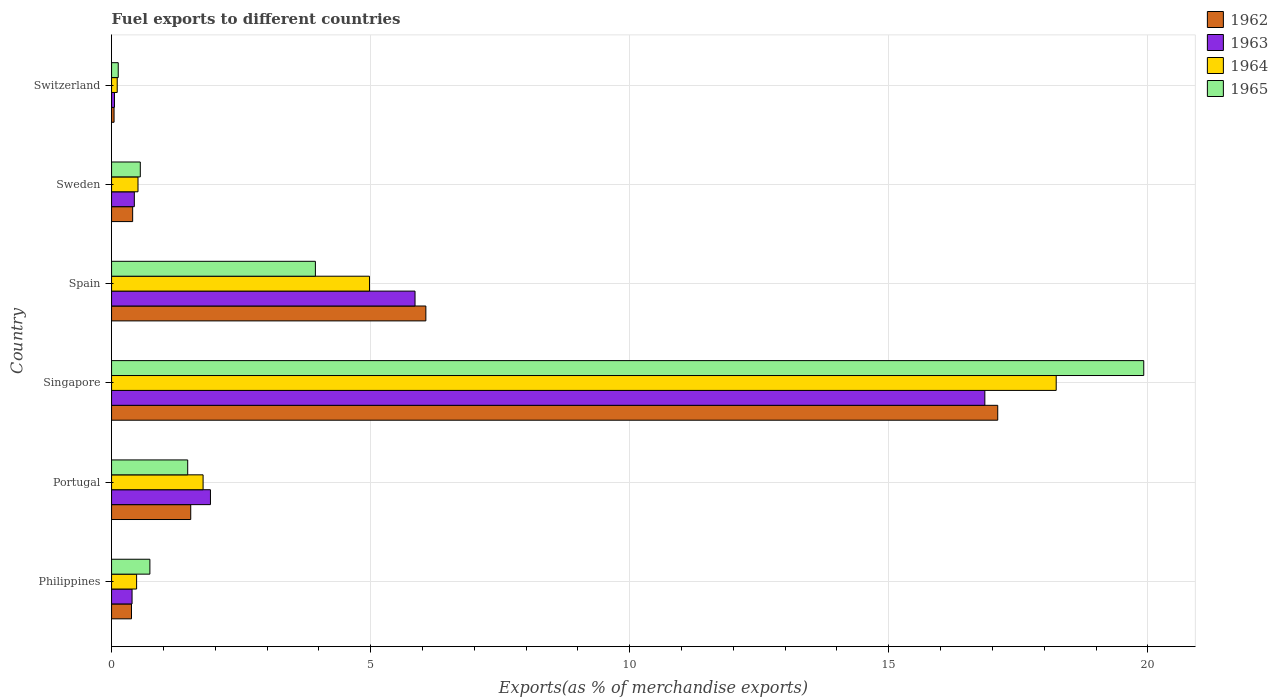Are the number of bars per tick equal to the number of legend labels?
Your answer should be very brief. Yes. Are the number of bars on each tick of the Y-axis equal?
Your answer should be compact. Yes. How many bars are there on the 4th tick from the top?
Your answer should be compact. 4. What is the label of the 2nd group of bars from the top?
Your response must be concise. Sweden. In how many cases, is the number of bars for a given country not equal to the number of legend labels?
Your response must be concise. 0. What is the percentage of exports to different countries in 1962 in Spain?
Give a very brief answer. 6.07. Across all countries, what is the maximum percentage of exports to different countries in 1963?
Your answer should be compact. 16.85. Across all countries, what is the minimum percentage of exports to different countries in 1962?
Provide a short and direct response. 0.05. In which country was the percentage of exports to different countries in 1965 maximum?
Your response must be concise. Singapore. In which country was the percentage of exports to different countries in 1962 minimum?
Give a very brief answer. Switzerland. What is the total percentage of exports to different countries in 1965 in the graph?
Offer a very short reply. 26.75. What is the difference between the percentage of exports to different countries in 1965 in Spain and that in Switzerland?
Make the answer very short. 3.81. What is the difference between the percentage of exports to different countries in 1965 in Switzerland and the percentage of exports to different countries in 1963 in Singapore?
Keep it short and to the point. -16.73. What is the average percentage of exports to different countries in 1963 per country?
Offer a terse response. 4.25. What is the difference between the percentage of exports to different countries in 1964 and percentage of exports to different countries in 1962 in Philippines?
Your answer should be very brief. 0.1. What is the ratio of the percentage of exports to different countries in 1962 in Philippines to that in Spain?
Keep it short and to the point. 0.06. What is the difference between the highest and the second highest percentage of exports to different countries in 1963?
Your answer should be very brief. 11. What is the difference between the highest and the lowest percentage of exports to different countries in 1963?
Offer a terse response. 16.8. What does the 2nd bar from the bottom in Portugal represents?
Give a very brief answer. 1963. Is it the case that in every country, the sum of the percentage of exports to different countries in 1963 and percentage of exports to different countries in 1965 is greater than the percentage of exports to different countries in 1964?
Offer a terse response. Yes. How many bars are there?
Ensure brevity in your answer.  24. Are all the bars in the graph horizontal?
Your response must be concise. Yes. Are the values on the major ticks of X-axis written in scientific E-notation?
Your response must be concise. No. Does the graph contain grids?
Your response must be concise. Yes. Where does the legend appear in the graph?
Offer a very short reply. Top right. How many legend labels are there?
Ensure brevity in your answer.  4. What is the title of the graph?
Your answer should be very brief. Fuel exports to different countries. Does "2002" appear as one of the legend labels in the graph?
Keep it short and to the point. No. What is the label or title of the X-axis?
Your answer should be very brief. Exports(as % of merchandise exports). What is the Exports(as % of merchandise exports) in 1962 in Philippines?
Your answer should be very brief. 0.38. What is the Exports(as % of merchandise exports) of 1963 in Philippines?
Keep it short and to the point. 0.4. What is the Exports(as % of merchandise exports) in 1964 in Philippines?
Provide a short and direct response. 0.48. What is the Exports(as % of merchandise exports) in 1965 in Philippines?
Offer a terse response. 0.74. What is the Exports(as % of merchandise exports) in 1962 in Portugal?
Offer a terse response. 1.53. What is the Exports(as % of merchandise exports) of 1963 in Portugal?
Provide a succinct answer. 1.91. What is the Exports(as % of merchandise exports) in 1964 in Portugal?
Your response must be concise. 1.77. What is the Exports(as % of merchandise exports) of 1965 in Portugal?
Provide a succinct answer. 1.47. What is the Exports(as % of merchandise exports) in 1962 in Singapore?
Offer a very short reply. 17.1. What is the Exports(as % of merchandise exports) of 1963 in Singapore?
Provide a succinct answer. 16.85. What is the Exports(as % of merchandise exports) in 1964 in Singapore?
Your answer should be compact. 18.23. What is the Exports(as % of merchandise exports) of 1965 in Singapore?
Offer a very short reply. 19.92. What is the Exports(as % of merchandise exports) of 1962 in Spain?
Make the answer very short. 6.07. What is the Exports(as % of merchandise exports) in 1963 in Spain?
Keep it short and to the point. 5.86. What is the Exports(as % of merchandise exports) in 1964 in Spain?
Give a very brief answer. 4.98. What is the Exports(as % of merchandise exports) of 1965 in Spain?
Offer a very short reply. 3.93. What is the Exports(as % of merchandise exports) in 1962 in Sweden?
Your answer should be very brief. 0.41. What is the Exports(as % of merchandise exports) in 1963 in Sweden?
Offer a very short reply. 0.44. What is the Exports(as % of merchandise exports) of 1964 in Sweden?
Offer a very short reply. 0.51. What is the Exports(as % of merchandise exports) in 1965 in Sweden?
Offer a terse response. 0.55. What is the Exports(as % of merchandise exports) in 1962 in Switzerland?
Keep it short and to the point. 0.05. What is the Exports(as % of merchandise exports) of 1963 in Switzerland?
Offer a terse response. 0.06. What is the Exports(as % of merchandise exports) in 1964 in Switzerland?
Keep it short and to the point. 0.11. What is the Exports(as % of merchandise exports) of 1965 in Switzerland?
Offer a terse response. 0.13. Across all countries, what is the maximum Exports(as % of merchandise exports) of 1962?
Offer a very short reply. 17.1. Across all countries, what is the maximum Exports(as % of merchandise exports) in 1963?
Give a very brief answer. 16.85. Across all countries, what is the maximum Exports(as % of merchandise exports) in 1964?
Provide a short and direct response. 18.23. Across all countries, what is the maximum Exports(as % of merchandise exports) of 1965?
Provide a succinct answer. 19.92. Across all countries, what is the minimum Exports(as % of merchandise exports) in 1962?
Keep it short and to the point. 0.05. Across all countries, what is the minimum Exports(as % of merchandise exports) in 1963?
Provide a short and direct response. 0.06. Across all countries, what is the minimum Exports(as % of merchandise exports) of 1964?
Offer a very short reply. 0.11. Across all countries, what is the minimum Exports(as % of merchandise exports) of 1965?
Offer a terse response. 0.13. What is the total Exports(as % of merchandise exports) of 1962 in the graph?
Your answer should be very brief. 25.54. What is the total Exports(as % of merchandise exports) of 1963 in the graph?
Provide a succinct answer. 25.51. What is the total Exports(as % of merchandise exports) of 1964 in the graph?
Give a very brief answer. 26.08. What is the total Exports(as % of merchandise exports) in 1965 in the graph?
Provide a succinct answer. 26.75. What is the difference between the Exports(as % of merchandise exports) of 1962 in Philippines and that in Portugal?
Give a very brief answer. -1.14. What is the difference between the Exports(as % of merchandise exports) in 1963 in Philippines and that in Portugal?
Offer a very short reply. -1.51. What is the difference between the Exports(as % of merchandise exports) in 1964 in Philippines and that in Portugal?
Offer a very short reply. -1.28. What is the difference between the Exports(as % of merchandise exports) in 1965 in Philippines and that in Portugal?
Your answer should be compact. -0.73. What is the difference between the Exports(as % of merchandise exports) of 1962 in Philippines and that in Singapore?
Provide a succinct answer. -16.72. What is the difference between the Exports(as % of merchandise exports) of 1963 in Philippines and that in Singapore?
Your response must be concise. -16.46. What is the difference between the Exports(as % of merchandise exports) in 1964 in Philippines and that in Singapore?
Offer a terse response. -17.75. What is the difference between the Exports(as % of merchandise exports) of 1965 in Philippines and that in Singapore?
Your answer should be compact. -19.18. What is the difference between the Exports(as % of merchandise exports) in 1962 in Philippines and that in Spain?
Provide a short and direct response. -5.68. What is the difference between the Exports(as % of merchandise exports) in 1963 in Philippines and that in Spain?
Offer a very short reply. -5.46. What is the difference between the Exports(as % of merchandise exports) of 1964 in Philippines and that in Spain?
Provide a succinct answer. -4.49. What is the difference between the Exports(as % of merchandise exports) of 1965 in Philippines and that in Spain?
Your answer should be compact. -3.19. What is the difference between the Exports(as % of merchandise exports) of 1962 in Philippines and that in Sweden?
Make the answer very short. -0.02. What is the difference between the Exports(as % of merchandise exports) of 1963 in Philippines and that in Sweden?
Ensure brevity in your answer.  -0.04. What is the difference between the Exports(as % of merchandise exports) of 1964 in Philippines and that in Sweden?
Provide a succinct answer. -0.03. What is the difference between the Exports(as % of merchandise exports) in 1965 in Philippines and that in Sweden?
Offer a terse response. 0.19. What is the difference between the Exports(as % of merchandise exports) in 1962 in Philippines and that in Switzerland?
Provide a short and direct response. 0.34. What is the difference between the Exports(as % of merchandise exports) of 1963 in Philippines and that in Switzerland?
Your answer should be very brief. 0.34. What is the difference between the Exports(as % of merchandise exports) of 1964 in Philippines and that in Switzerland?
Your answer should be compact. 0.37. What is the difference between the Exports(as % of merchandise exports) of 1965 in Philippines and that in Switzerland?
Give a very brief answer. 0.61. What is the difference between the Exports(as % of merchandise exports) in 1962 in Portugal and that in Singapore?
Offer a terse response. -15.58. What is the difference between the Exports(as % of merchandise exports) in 1963 in Portugal and that in Singapore?
Your answer should be very brief. -14.95. What is the difference between the Exports(as % of merchandise exports) in 1964 in Portugal and that in Singapore?
Give a very brief answer. -16.47. What is the difference between the Exports(as % of merchandise exports) of 1965 in Portugal and that in Singapore?
Offer a very short reply. -18.45. What is the difference between the Exports(as % of merchandise exports) of 1962 in Portugal and that in Spain?
Keep it short and to the point. -4.54. What is the difference between the Exports(as % of merchandise exports) of 1963 in Portugal and that in Spain?
Your answer should be very brief. -3.95. What is the difference between the Exports(as % of merchandise exports) of 1964 in Portugal and that in Spain?
Your answer should be compact. -3.21. What is the difference between the Exports(as % of merchandise exports) in 1965 in Portugal and that in Spain?
Offer a terse response. -2.46. What is the difference between the Exports(as % of merchandise exports) in 1962 in Portugal and that in Sweden?
Offer a terse response. 1.12. What is the difference between the Exports(as % of merchandise exports) in 1963 in Portugal and that in Sweden?
Give a very brief answer. 1.47. What is the difference between the Exports(as % of merchandise exports) in 1964 in Portugal and that in Sweden?
Make the answer very short. 1.26. What is the difference between the Exports(as % of merchandise exports) of 1965 in Portugal and that in Sweden?
Your answer should be very brief. 0.91. What is the difference between the Exports(as % of merchandise exports) of 1962 in Portugal and that in Switzerland?
Ensure brevity in your answer.  1.48. What is the difference between the Exports(as % of merchandise exports) of 1963 in Portugal and that in Switzerland?
Provide a succinct answer. 1.85. What is the difference between the Exports(as % of merchandise exports) of 1964 in Portugal and that in Switzerland?
Provide a succinct answer. 1.66. What is the difference between the Exports(as % of merchandise exports) of 1965 in Portugal and that in Switzerland?
Ensure brevity in your answer.  1.34. What is the difference between the Exports(as % of merchandise exports) in 1962 in Singapore and that in Spain?
Offer a very short reply. 11.04. What is the difference between the Exports(as % of merchandise exports) in 1963 in Singapore and that in Spain?
Offer a very short reply. 11. What is the difference between the Exports(as % of merchandise exports) in 1964 in Singapore and that in Spain?
Provide a succinct answer. 13.25. What is the difference between the Exports(as % of merchandise exports) of 1965 in Singapore and that in Spain?
Make the answer very short. 15.99. What is the difference between the Exports(as % of merchandise exports) in 1962 in Singapore and that in Sweden?
Your answer should be compact. 16.7. What is the difference between the Exports(as % of merchandise exports) in 1963 in Singapore and that in Sweden?
Ensure brevity in your answer.  16.42. What is the difference between the Exports(as % of merchandise exports) of 1964 in Singapore and that in Sweden?
Provide a short and direct response. 17.72. What is the difference between the Exports(as % of merchandise exports) of 1965 in Singapore and that in Sweden?
Make the answer very short. 19.37. What is the difference between the Exports(as % of merchandise exports) of 1962 in Singapore and that in Switzerland?
Your answer should be very brief. 17.06. What is the difference between the Exports(as % of merchandise exports) of 1963 in Singapore and that in Switzerland?
Offer a terse response. 16.8. What is the difference between the Exports(as % of merchandise exports) of 1964 in Singapore and that in Switzerland?
Offer a terse response. 18.12. What is the difference between the Exports(as % of merchandise exports) in 1965 in Singapore and that in Switzerland?
Your answer should be very brief. 19.79. What is the difference between the Exports(as % of merchandise exports) of 1962 in Spain and that in Sweden?
Offer a terse response. 5.66. What is the difference between the Exports(as % of merchandise exports) of 1963 in Spain and that in Sweden?
Keep it short and to the point. 5.42. What is the difference between the Exports(as % of merchandise exports) of 1964 in Spain and that in Sweden?
Give a very brief answer. 4.47. What is the difference between the Exports(as % of merchandise exports) of 1965 in Spain and that in Sweden?
Your answer should be very brief. 3.38. What is the difference between the Exports(as % of merchandise exports) of 1962 in Spain and that in Switzerland?
Provide a succinct answer. 6.02. What is the difference between the Exports(as % of merchandise exports) of 1963 in Spain and that in Switzerland?
Give a very brief answer. 5.8. What is the difference between the Exports(as % of merchandise exports) of 1964 in Spain and that in Switzerland?
Provide a succinct answer. 4.87. What is the difference between the Exports(as % of merchandise exports) of 1965 in Spain and that in Switzerland?
Your answer should be very brief. 3.81. What is the difference between the Exports(as % of merchandise exports) of 1962 in Sweden and that in Switzerland?
Your answer should be compact. 0.36. What is the difference between the Exports(as % of merchandise exports) of 1963 in Sweden and that in Switzerland?
Provide a succinct answer. 0.38. What is the difference between the Exports(as % of merchandise exports) of 1964 in Sweden and that in Switzerland?
Make the answer very short. 0.4. What is the difference between the Exports(as % of merchandise exports) of 1965 in Sweden and that in Switzerland?
Offer a very short reply. 0.43. What is the difference between the Exports(as % of merchandise exports) in 1962 in Philippines and the Exports(as % of merchandise exports) in 1963 in Portugal?
Provide a short and direct response. -1.52. What is the difference between the Exports(as % of merchandise exports) of 1962 in Philippines and the Exports(as % of merchandise exports) of 1964 in Portugal?
Make the answer very short. -1.38. What is the difference between the Exports(as % of merchandise exports) in 1962 in Philippines and the Exports(as % of merchandise exports) in 1965 in Portugal?
Ensure brevity in your answer.  -1.08. What is the difference between the Exports(as % of merchandise exports) of 1963 in Philippines and the Exports(as % of merchandise exports) of 1964 in Portugal?
Offer a terse response. -1.37. What is the difference between the Exports(as % of merchandise exports) of 1963 in Philippines and the Exports(as % of merchandise exports) of 1965 in Portugal?
Provide a short and direct response. -1.07. What is the difference between the Exports(as % of merchandise exports) of 1964 in Philippines and the Exports(as % of merchandise exports) of 1965 in Portugal?
Keep it short and to the point. -0.99. What is the difference between the Exports(as % of merchandise exports) in 1962 in Philippines and the Exports(as % of merchandise exports) in 1963 in Singapore?
Provide a succinct answer. -16.47. What is the difference between the Exports(as % of merchandise exports) in 1962 in Philippines and the Exports(as % of merchandise exports) in 1964 in Singapore?
Provide a succinct answer. -17.85. What is the difference between the Exports(as % of merchandise exports) in 1962 in Philippines and the Exports(as % of merchandise exports) in 1965 in Singapore?
Give a very brief answer. -19.54. What is the difference between the Exports(as % of merchandise exports) of 1963 in Philippines and the Exports(as % of merchandise exports) of 1964 in Singapore?
Ensure brevity in your answer.  -17.84. What is the difference between the Exports(as % of merchandise exports) of 1963 in Philippines and the Exports(as % of merchandise exports) of 1965 in Singapore?
Offer a terse response. -19.53. What is the difference between the Exports(as % of merchandise exports) of 1964 in Philippines and the Exports(as % of merchandise exports) of 1965 in Singapore?
Your response must be concise. -19.44. What is the difference between the Exports(as % of merchandise exports) in 1962 in Philippines and the Exports(as % of merchandise exports) in 1963 in Spain?
Make the answer very short. -5.47. What is the difference between the Exports(as % of merchandise exports) in 1962 in Philippines and the Exports(as % of merchandise exports) in 1964 in Spain?
Your answer should be compact. -4.59. What is the difference between the Exports(as % of merchandise exports) of 1962 in Philippines and the Exports(as % of merchandise exports) of 1965 in Spain?
Give a very brief answer. -3.55. What is the difference between the Exports(as % of merchandise exports) of 1963 in Philippines and the Exports(as % of merchandise exports) of 1964 in Spain?
Your answer should be very brief. -4.58. What is the difference between the Exports(as % of merchandise exports) of 1963 in Philippines and the Exports(as % of merchandise exports) of 1965 in Spain?
Offer a very short reply. -3.54. What is the difference between the Exports(as % of merchandise exports) of 1964 in Philippines and the Exports(as % of merchandise exports) of 1965 in Spain?
Your answer should be compact. -3.45. What is the difference between the Exports(as % of merchandise exports) of 1962 in Philippines and the Exports(as % of merchandise exports) of 1963 in Sweden?
Make the answer very short. -0.05. What is the difference between the Exports(as % of merchandise exports) of 1962 in Philippines and the Exports(as % of merchandise exports) of 1964 in Sweden?
Your response must be concise. -0.13. What is the difference between the Exports(as % of merchandise exports) of 1962 in Philippines and the Exports(as % of merchandise exports) of 1965 in Sweden?
Your response must be concise. -0.17. What is the difference between the Exports(as % of merchandise exports) of 1963 in Philippines and the Exports(as % of merchandise exports) of 1964 in Sweden?
Your answer should be very brief. -0.11. What is the difference between the Exports(as % of merchandise exports) in 1963 in Philippines and the Exports(as % of merchandise exports) in 1965 in Sweden?
Your answer should be compact. -0.16. What is the difference between the Exports(as % of merchandise exports) of 1964 in Philippines and the Exports(as % of merchandise exports) of 1965 in Sweden?
Provide a succinct answer. -0.07. What is the difference between the Exports(as % of merchandise exports) in 1962 in Philippines and the Exports(as % of merchandise exports) in 1963 in Switzerland?
Keep it short and to the point. 0.33. What is the difference between the Exports(as % of merchandise exports) of 1962 in Philippines and the Exports(as % of merchandise exports) of 1964 in Switzerland?
Make the answer very short. 0.28. What is the difference between the Exports(as % of merchandise exports) of 1962 in Philippines and the Exports(as % of merchandise exports) of 1965 in Switzerland?
Offer a very short reply. 0.26. What is the difference between the Exports(as % of merchandise exports) of 1963 in Philippines and the Exports(as % of merchandise exports) of 1964 in Switzerland?
Keep it short and to the point. 0.29. What is the difference between the Exports(as % of merchandise exports) in 1963 in Philippines and the Exports(as % of merchandise exports) in 1965 in Switzerland?
Keep it short and to the point. 0.27. What is the difference between the Exports(as % of merchandise exports) in 1964 in Philippines and the Exports(as % of merchandise exports) in 1965 in Switzerland?
Ensure brevity in your answer.  0.35. What is the difference between the Exports(as % of merchandise exports) of 1962 in Portugal and the Exports(as % of merchandise exports) of 1963 in Singapore?
Keep it short and to the point. -15.33. What is the difference between the Exports(as % of merchandise exports) of 1962 in Portugal and the Exports(as % of merchandise exports) of 1964 in Singapore?
Provide a short and direct response. -16.7. What is the difference between the Exports(as % of merchandise exports) of 1962 in Portugal and the Exports(as % of merchandise exports) of 1965 in Singapore?
Provide a short and direct response. -18.39. What is the difference between the Exports(as % of merchandise exports) in 1963 in Portugal and the Exports(as % of merchandise exports) in 1964 in Singapore?
Offer a terse response. -16.32. What is the difference between the Exports(as % of merchandise exports) in 1963 in Portugal and the Exports(as % of merchandise exports) in 1965 in Singapore?
Your response must be concise. -18.01. What is the difference between the Exports(as % of merchandise exports) in 1964 in Portugal and the Exports(as % of merchandise exports) in 1965 in Singapore?
Make the answer very short. -18.16. What is the difference between the Exports(as % of merchandise exports) of 1962 in Portugal and the Exports(as % of merchandise exports) of 1963 in Spain?
Give a very brief answer. -4.33. What is the difference between the Exports(as % of merchandise exports) of 1962 in Portugal and the Exports(as % of merchandise exports) of 1964 in Spain?
Make the answer very short. -3.45. What is the difference between the Exports(as % of merchandise exports) of 1962 in Portugal and the Exports(as % of merchandise exports) of 1965 in Spain?
Provide a short and direct response. -2.41. What is the difference between the Exports(as % of merchandise exports) of 1963 in Portugal and the Exports(as % of merchandise exports) of 1964 in Spain?
Your answer should be compact. -3.07. What is the difference between the Exports(as % of merchandise exports) of 1963 in Portugal and the Exports(as % of merchandise exports) of 1965 in Spain?
Keep it short and to the point. -2.03. What is the difference between the Exports(as % of merchandise exports) of 1964 in Portugal and the Exports(as % of merchandise exports) of 1965 in Spain?
Your response must be concise. -2.17. What is the difference between the Exports(as % of merchandise exports) in 1962 in Portugal and the Exports(as % of merchandise exports) in 1963 in Sweden?
Offer a terse response. 1.09. What is the difference between the Exports(as % of merchandise exports) in 1962 in Portugal and the Exports(as % of merchandise exports) in 1964 in Sweden?
Offer a very short reply. 1.02. What is the difference between the Exports(as % of merchandise exports) of 1962 in Portugal and the Exports(as % of merchandise exports) of 1965 in Sweden?
Offer a very short reply. 0.97. What is the difference between the Exports(as % of merchandise exports) of 1963 in Portugal and the Exports(as % of merchandise exports) of 1964 in Sweden?
Ensure brevity in your answer.  1.4. What is the difference between the Exports(as % of merchandise exports) of 1963 in Portugal and the Exports(as % of merchandise exports) of 1965 in Sweden?
Make the answer very short. 1.35. What is the difference between the Exports(as % of merchandise exports) of 1964 in Portugal and the Exports(as % of merchandise exports) of 1965 in Sweden?
Your answer should be compact. 1.21. What is the difference between the Exports(as % of merchandise exports) of 1962 in Portugal and the Exports(as % of merchandise exports) of 1963 in Switzerland?
Provide a succinct answer. 1.47. What is the difference between the Exports(as % of merchandise exports) in 1962 in Portugal and the Exports(as % of merchandise exports) in 1964 in Switzerland?
Offer a very short reply. 1.42. What is the difference between the Exports(as % of merchandise exports) in 1962 in Portugal and the Exports(as % of merchandise exports) in 1965 in Switzerland?
Offer a very short reply. 1.4. What is the difference between the Exports(as % of merchandise exports) of 1963 in Portugal and the Exports(as % of merchandise exports) of 1964 in Switzerland?
Your answer should be compact. 1.8. What is the difference between the Exports(as % of merchandise exports) in 1963 in Portugal and the Exports(as % of merchandise exports) in 1965 in Switzerland?
Ensure brevity in your answer.  1.78. What is the difference between the Exports(as % of merchandise exports) in 1964 in Portugal and the Exports(as % of merchandise exports) in 1965 in Switzerland?
Provide a succinct answer. 1.64. What is the difference between the Exports(as % of merchandise exports) of 1962 in Singapore and the Exports(as % of merchandise exports) of 1963 in Spain?
Your answer should be very brief. 11.25. What is the difference between the Exports(as % of merchandise exports) in 1962 in Singapore and the Exports(as % of merchandise exports) in 1964 in Spain?
Make the answer very short. 12.13. What is the difference between the Exports(as % of merchandise exports) in 1962 in Singapore and the Exports(as % of merchandise exports) in 1965 in Spain?
Ensure brevity in your answer.  13.17. What is the difference between the Exports(as % of merchandise exports) of 1963 in Singapore and the Exports(as % of merchandise exports) of 1964 in Spain?
Your response must be concise. 11.88. What is the difference between the Exports(as % of merchandise exports) in 1963 in Singapore and the Exports(as % of merchandise exports) in 1965 in Spain?
Make the answer very short. 12.92. What is the difference between the Exports(as % of merchandise exports) in 1964 in Singapore and the Exports(as % of merchandise exports) in 1965 in Spain?
Make the answer very short. 14.3. What is the difference between the Exports(as % of merchandise exports) in 1962 in Singapore and the Exports(as % of merchandise exports) in 1963 in Sweden?
Make the answer very short. 16.66. What is the difference between the Exports(as % of merchandise exports) of 1962 in Singapore and the Exports(as % of merchandise exports) of 1964 in Sweden?
Make the answer very short. 16.59. What is the difference between the Exports(as % of merchandise exports) of 1962 in Singapore and the Exports(as % of merchandise exports) of 1965 in Sweden?
Your answer should be very brief. 16.55. What is the difference between the Exports(as % of merchandise exports) of 1963 in Singapore and the Exports(as % of merchandise exports) of 1964 in Sweden?
Provide a short and direct response. 16.34. What is the difference between the Exports(as % of merchandise exports) of 1963 in Singapore and the Exports(as % of merchandise exports) of 1965 in Sweden?
Offer a very short reply. 16.3. What is the difference between the Exports(as % of merchandise exports) of 1964 in Singapore and the Exports(as % of merchandise exports) of 1965 in Sweden?
Provide a succinct answer. 17.68. What is the difference between the Exports(as % of merchandise exports) in 1962 in Singapore and the Exports(as % of merchandise exports) in 1963 in Switzerland?
Your response must be concise. 17.05. What is the difference between the Exports(as % of merchandise exports) in 1962 in Singapore and the Exports(as % of merchandise exports) in 1964 in Switzerland?
Give a very brief answer. 16.99. What is the difference between the Exports(as % of merchandise exports) in 1962 in Singapore and the Exports(as % of merchandise exports) in 1965 in Switzerland?
Ensure brevity in your answer.  16.97. What is the difference between the Exports(as % of merchandise exports) in 1963 in Singapore and the Exports(as % of merchandise exports) in 1964 in Switzerland?
Give a very brief answer. 16.75. What is the difference between the Exports(as % of merchandise exports) of 1963 in Singapore and the Exports(as % of merchandise exports) of 1965 in Switzerland?
Ensure brevity in your answer.  16.73. What is the difference between the Exports(as % of merchandise exports) of 1964 in Singapore and the Exports(as % of merchandise exports) of 1965 in Switzerland?
Provide a succinct answer. 18.1. What is the difference between the Exports(as % of merchandise exports) in 1962 in Spain and the Exports(as % of merchandise exports) in 1963 in Sweden?
Your answer should be compact. 5.63. What is the difference between the Exports(as % of merchandise exports) of 1962 in Spain and the Exports(as % of merchandise exports) of 1964 in Sweden?
Make the answer very short. 5.56. What is the difference between the Exports(as % of merchandise exports) in 1962 in Spain and the Exports(as % of merchandise exports) in 1965 in Sweden?
Ensure brevity in your answer.  5.51. What is the difference between the Exports(as % of merchandise exports) of 1963 in Spain and the Exports(as % of merchandise exports) of 1964 in Sweden?
Provide a short and direct response. 5.35. What is the difference between the Exports(as % of merchandise exports) in 1963 in Spain and the Exports(as % of merchandise exports) in 1965 in Sweden?
Make the answer very short. 5.3. What is the difference between the Exports(as % of merchandise exports) of 1964 in Spain and the Exports(as % of merchandise exports) of 1965 in Sweden?
Provide a succinct answer. 4.42. What is the difference between the Exports(as % of merchandise exports) in 1962 in Spain and the Exports(as % of merchandise exports) in 1963 in Switzerland?
Your response must be concise. 6.01. What is the difference between the Exports(as % of merchandise exports) of 1962 in Spain and the Exports(as % of merchandise exports) of 1964 in Switzerland?
Your answer should be very brief. 5.96. What is the difference between the Exports(as % of merchandise exports) in 1962 in Spain and the Exports(as % of merchandise exports) in 1965 in Switzerland?
Keep it short and to the point. 5.94. What is the difference between the Exports(as % of merchandise exports) in 1963 in Spain and the Exports(as % of merchandise exports) in 1964 in Switzerland?
Your answer should be compact. 5.75. What is the difference between the Exports(as % of merchandise exports) in 1963 in Spain and the Exports(as % of merchandise exports) in 1965 in Switzerland?
Offer a terse response. 5.73. What is the difference between the Exports(as % of merchandise exports) of 1964 in Spain and the Exports(as % of merchandise exports) of 1965 in Switzerland?
Offer a terse response. 4.85. What is the difference between the Exports(as % of merchandise exports) of 1962 in Sweden and the Exports(as % of merchandise exports) of 1963 in Switzerland?
Provide a succinct answer. 0.35. What is the difference between the Exports(as % of merchandise exports) in 1962 in Sweden and the Exports(as % of merchandise exports) in 1964 in Switzerland?
Provide a succinct answer. 0.3. What is the difference between the Exports(as % of merchandise exports) in 1962 in Sweden and the Exports(as % of merchandise exports) in 1965 in Switzerland?
Provide a short and direct response. 0.28. What is the difference between the Exports(as % of merchandise exports) of 1963 in Sweden and the Exports(as % of merchandise exports) of 1964 in Switzerland?
Offer a terse response. 0.33. What is the difference between the Exports(as % of merchandise exports) in 1963 in Sweden and the Exports(as % of merchandise exports) in 1965 in Switzerland?
Give a very brief answer. 0.31. What is the difference between the Exports(as % of merchandise exports) of 1964 in Sweden and the Exports(as % of merchandise exports) of 1965 in Switzerland?
Your answer should be very brief. 0.38. What is the average Exports(as % of merchandise exports) of 1962 per country?
Provide a succinct answer. 4.26. What is the average Exports(as % of merchandise exports) in 1963 per country?
Offer a very short reply. 4.25. What is the average Exports(as % of merchandise exports) of 1964 per country?
Your answer should be compact. 4.35. What is the average Exports(as % of merchandise exports) in 1965 per country?
Keep it short and to the point. 4.46. What is the difference between the Exports(as % of merchandise exports) of 1962 and Exports(as % of merchandise exports) of 1963 in Philippines?
Offer a very short reply. -0.01. What is the difference between the Exports(as % of merchandise exports) in 1962 and Exports(as % of merchandise exports) in 1964 in Philippines?
Keep it short and to the point. -0.1. What is the difference between the Exports(as % of merchandise exports) of 1962 and Exports(as % of merchandise exports) of 1965 in Philippines?
Ensure brevity in your answer.  -0.35. What is the difference between the Exports(as % of merchandise exports) of 1963 and Exports(as % of merchandise exports) of 1964 in Philippines?
Give a very brief answer. -0.09. What is the difference between the Exports(as % of merchandise exports) in 1963 and Exports(as % of merchandise exports) in 1965 in Philippines?
Provide a short and direct response. -0.34. What is the difference between the Exports(as % of merchandise exports) in 1964 and Exports(as % of merchandise exports) in 1965 in Philippines?
Offer a very short reply. -0.26. What is the difference between the Exports(as % of merchandise exports) of 1962 and Exports(as % of merchandise exports) of 1963 in Portugal?
Offer a very short reply. -0.38. What is the difference between the Exports(as % of merchandise exports) of 1962 and Exports(as % of merchandise exports) of 1964 in Portugal?
Provide a succinct answer. -0.24. What is the difference between the Exports(as % of merchandise exports) of 1962 and Exports(as % of merchandise exports) of 1965 in Portugal?
Give a very brief answer. 0.06. What is the difference between the Exports(as % of merchandise exports) in 1963 and Exports(as % of merchandise exports) in 1964 in Portugal?
Offer a terse response. 0.14. What is the difference between the Exports(as % of merchandise exports) in 1963 and Exports(as % of merchandise exports) in 1965 in Portugal?
Make the answer very short. 0.44. What is the difference between the Exports(as % of merchandise exports) of 1964 and Exports(as % of merchandise exports) of 1965 in Portugal?
Your answer should be very brief. 0.3. What is the difference between the Exports(as % of merchandise exports) of 1962 and Exports(as % of merchandise exports) of 1963 in Singapore?
Provide a succinct answer. 0.25. What is the difference between the Exports(as % of merchandise exports) in 1962 and Exports(as % of merchandise exports) in 1964 in Singapore?
Offer a terse response. -1.13. What is the difference between the Exports(as % of merchandise exports) in 1962 and Exports(as % of merchandise exports) in 1965 in Singapore?
Offer a terse response. -2.82. What is the difference between the Exports(as % of merchandise exports) in 1963 and Exports(as % of merchandise exports) in 1964 in Singapore?
Provide a succinct answer. -1.38. What is the difference between the Exports(as % of merchandise exports) in 1963 and Exports(as % of merchandise exports) in 1965 in Singapore?
Your answer should be compact. -3.07. What is the difference between the Exports(as % of merchandise exports) of 1964 and Exports(as % of merchandise exports) of 1965 in Singapore?
Your answer should be very brief. -1.69. What is the difference between the Exports(as % of merchandise exports) of 1962 and Exports(as % of merchandise exports) of 1963 in Spain?
Make the answer very short. 0.21. What is the difference between the Exports(as % of merchandise exports) of 1962 and Exports(as % of merchandise exports) of 1964 in Spain?
Keep it short and to the point. 1.09. What is the difference between the Exports(as % of merchandise exports) of 1962 and Exports(as % of merchandise exports) of 1965 in Spain?
Ensure brevity in your answer.  2.13. What is the difference between the Exports(as % of merchandise exports) in 1963 and Exports(as % of merchandise exports) in 1964 in Spain?
Offer a terse response. 0.88. What is the difference between the Exports(as % of merchandise exports) in 1963 and Exports(as % of merchandise exports) in 1965 in Spain?
Offer a very short reply. 1.92. What is the difference between the Exports(as % of merchandise exports) in 1964 and Exports(as % of merchandise exports) in 1965 in Spain?
Provide a succinct answer. 1.04. What is the difference between the Exports(as % of merchandise exports) in 1962 and Exports(as % of merchandise exports) in 1963 in Sweden?
Make the answer very short. -0.03. What is the difference between the Exports(as % of merchandise exports) in 1962 and Exports(as % of merchandise exports) in 1964 in Sweden?
Provide a short and direct response. -0.1. What is the difference between the Exports(as % of merchandise exports) of 1962 and Exports(as % of merchandise exports) of 1965 in Sweden?
Give a very brief answer. -0.15. What is the difference between the Exports(as % of merchandise exports) in 1963 and Exports(as % of merchandise exports) in 1964 in Sweden?
Make the answer very short. -0.07. What is the difference between the Exports(as % of merchandise exports) in 1963 and Exports(as % of merchandise exports) in 1965 in Sweden?
Your response must be concise. -0.12. What is the difference between the Exports(as % of merchandise exports) in 1964 and Exports(as % of merchandise exports) in 1965 in Sweden?
Provide a short and direct response. -0.04. What is the difference between the Exports(as % of merchandise exports) of 1962 and Exports(as % of merchandise exports) of 1963 in Switzerland?
Ensure brevity in your answer.  -0.01. What is the difference between the Exports(as % of merchandise exports) of 1962 and Exports(as % of merchandise exports) of 1964 in Switzerland?
Ensure brevity in your answer.  -0.06. What is the difference between the Exports(as % of merchandise exports) of 1962 and Exports(as % of merchandise exports) of 1965 in Switzerland?
Your response must be concise. -0.08. What is the difference between the Exports(as % of merchandise exports) in 1963 and Exports(as % of merchandise exports) in 1964 in Switzerland?
Make the answer very short. -0.05. What is the difference between the Exports(as % of merchandise exports) in 1963 and Exports(as % of merchandise exports) in 1965 in Switzerland?
Keep it short and to the point. -0.07. What is the difference between the Exports(as % of merchandise exports) of 1964 and Exports(as % of merchandise exports) of 1965 in Switzerland?
Keep it short and to the point. -0.02. What is the ratio of the Exports(as % of merchandise exports) in 1962 in Philippines to that in Portugal?
Provide a succinct answer. 0.25. What is the ratio of the Exports(as % of merchandise exports) of 1963 in Philippines to that in Portugal?
Offer a terse response. 0.21. What is the ratio of the Exports(as % of merchandise exports) in 1964 in Philippines to that in Portugal?
Your answer should be compact. 0.27. What is the ratio of the Exports(as % of merchandise exports) in 1965 in Philippines to that in Portugal?
Ensure brevity in your answer.  0.5. What is the ratio of the Exports(as % of merchandise exports) of 1962 in Philippines to that in Singapore?
Your answer should be very brief. 0.02. What is the ratio of the Exports(as % of merchandise exports) of 1963 in Philippines to that in Singapore?
Give a very brief answer. 0.02. What is the ratio of the Exports(as % of merchandise exports) of 1964 in Philippines to that in Singapore?
Provide a succinct answer. 0.03. What is the ratio of the Exports(as % of merchandise exports) of 1965 in Philippines to that in Singapore?
Give a very brief answer. 0.04. What is the ratio of the Exports(as % of merchandise exports) of 1962 in Philippines to that in Spain?
Keep it short and to the point. 0.06. What is the ratio of the Exports(as % of merchandise exports) in 1963 in Philippines to that in Spain?
Your answer should be compact. 0.07. What is the ratio of the Exports(as % of merchandise exports) in 1964 in Philippines to that in Spain?
Your answer should be very brief. 0.1. What is the ratio of the Exports(as % of merchandise exports) in 1965 in Philippines to that in Spain?
Provide a succinct answer. 0.19. What is the ratio of the Exports(as % of merchandise exports) in 1962 in Philippines to that in Sweden?
Your answer should be compact. 0.94. What is the ratio of the Exports(as % of merchandise exports) in 1963 in Philippines to that in Sweden?
Give a very brief answer. 0.9. What is the ratio of the Exports(as % of merchandise exports) in 1964 in Philippines to that in Sweden?
Your answer should be very brief. 0.95. What is the ratio of the Exports(as % of merchandise exports) of 1965 in Philippines to that in Sweden?
Provide a succinct answer. 1.33. What is the ratio of the Exports(as % of merchandise exports) in 1962 in Philippines to that in Switzerland?
Make the answer very short. 7.98. What is the ratio of the Exports(as % of merchandise exports) in 1963 in Philippines to that in Switzerland?
Make the answer very short. 7.04. What is the ratio of the Exports(as % of merchandise exports) in 1964 in Philippines to that in Switzerland?
Provide a short and direct response. 4.43. What is the ratio of the Exports(as % of merchandise exports) in 1965 in Philippines to that in Switzerland?
Provide a short and direct response. 5.74. What is the ratio of the Exports(as % of merchandise exports) of 1962 in Portugal to that in Singapore?
Your response must be concise. 0.09. What is the ratio of the Exports(as % of merchandise exports) in 1963 in Portugal to that in Singapore?
Offer a very short reply. 0.11. What is the ratio of the Exports(as % of merchandise exports) of 1964 in Portugal to that in Singapore?
Provide a succinct answer. 0.1. What is the ratio of the Exports(as % of merchandise exports) in 1965 in Portugal to that in Singapore?
Your answer should be very brief. 0.07. What is the ratio of the Exports(as % of merchandise exports) of 1962 in Portugal to that in Spain?
Offer a terse response. 0.25. What is the ratio of the Exports(as % of merchandise exports) of 1963 in Portugal to that in Spain?
Make the answer very short. 0.33. What is the ratio of the Exports(as % of merchandise exports) of 1964 in Portugal to that in Spain?
Your answer should be compact. 0.35. What is the ratio of the Exports(as % of merchandise exports) in 1965 in Portugal to that in Spain?
Offer a very short reply. 0.37. What is the ratio of the Exports(as % of merchandise exports) of 1962 in Portugal to that in Sweden?
Provide a short and direct response. 3.75. What is the ratio of the Exports(as % of merchandise exports) in 1963 in Portugal to that in Sweden?
Offer a terse response. 4.34. What is the ratio of the Exports(as % of merchandise exports) of 1964 in Portugal to that in Sweden?
Keep it short and to the point. 3.46. What is the ratio of the Exports(as % of merchandise exports) in 1965 in Portugal to that in Sweden?
Ensure brevity in your answer.  2.65. What is the ratio of the Exports(as % of merchandise exports) of 1962 in Portugal to that in Switzerland?
Your response must be concise. 31.67. What is the ratio of the Exports(as % of merchandise exports) of 1963 in Portugal to that in Switzerland?
Your response must be concise. 33.93. What is the ratio of the Exports(as % of merchandise exports) of 1964 in Portugal to that in Switzerland?
Keep it short and to the point. 16.19. What is the ratio of the Exports(as % of merchandise exports) of 1965 in Portugal to that in Switzerland?
Your answer should be very brief. 11.41. What is the ratio of the Exports(as % of merchandise exports) in 1962 in Singapore to that in Spain?
Make the answer very short. 2.82. What is the ratio of the Exports(as % of merchandise exports) of 1963 in Singapore to that in Spain?
Keep it short and to the point. 2.88. What is the ratio of the Exports(as % of merchandise exports) of 1964 in Singapore to that in Spain?
Provide a short and direct response. 3.66. What is the ratio of the Exports(as % of merchandise exports) of 1965 in Singapore to that in Spain?
Offer a very short reply. 5.06. What is the ratio of the Exports(as % of merchandise exports) in 1962 in Singapore to that in Sweden?
Provide a short and direct response. 41.99. What is the ratio of the Exports(as % of merchandise exports) in 1963 in Singapore to that in Sweden?
Ensure brevity in your answer.  38.35. What is the ratio of the Exports(as % of merchandise exports) in 1964 in Singapore to that in Sweden?
Your answer should be very brief. 35.72. What is the ratio of the Exports(as % of merchandise exports) in 1965 in Singapore to that in Sweden?
Your answer should be very brief. 35.92. What is the ratio of the Exports(as % of merchandise exports) in 1962 in Singapore to that in Switzerland?
Offer a terse response. 354.54. What is the ratio of the Exports(as % of merchandise exports) of 1963 in Singapore to that in Switzerland?
Offer a terse response. 299.62. What is the ratio of the Exports(as % of merchandise exports) in 1964 in Singapore to that in Switzerland?
Provide a short and direct response. 167.06. What is the ratio of the Exports(as % of merchandise exports) of 1965 in Singapore to that in Switzerland?
Offer a very short reply. 154.67. What is the ratio of the Exports(as % of merchandise exports) of 1962 in Spain to that in Sweden?
Offer a very short reply. 14.89. What is the ratio of the Exports(as % of merchandise exports) of 1963 in Spain to that in Sweden?
Offer a terse response. 13.33. What is the ratio of the Exports(as % of merchandise exports) of 1964 in Spain to that in Sweden?
Offer a very short reply. 9.75. What is the ratio of the Exports(as % of merchandise exports) of 1965 in Spain to that in Sweden?
Your response must be concise. 7.09. What is the ratio of the Exports(as % of merchandise exports) of 1962 in Spain to that in Switzerland?
Offer a very short reply. 125.74. What is the ratio of the Exports(as % of merchandise exports) of 1963 in Spain to that in Switzerland?
Your answer should be very brief. 104.12. What is the ratio of the Exports(as % of merchandise exports) in 1964 in Spain to that in Switzerland?
Offer a very short reply. 45.62. What is the ratio of the Exports(as % of merchandise exports) of 1965 in Spain to that in Switzerland?
Make the answer very short. 30.54. What is the ratio of the Exports(as % of merchandise exports) of 1962 in Sweden to that in Switzerland?
Give a very brief answer. 8.44. What is the ratio of the Exports(as % of merchandise exports) in 1963 in Sweden to that in Switzerland?
Your response must be concise. 7.81. What is the ratio of the Exports(as % of merchandise exports) of 1964 in Sweden to that in Switzerland?
Keep it short and to the point. 4.68. What is the ratio of the Exports(as % of merchandise exports) in 1965 in Sweden to that in Switzerland?
Offer a very short reply. 4.31. What is the difference between the highest and the second highest Exports(as % of merchandise exports) in 1962?
Your answer should be very brief. 11.04. What is the difference between the highest and the second highest Exports(as % of merchandise exports) in 1963?
Keep it short and to the point. 11. What is the difference between the highest and the second highest Exports(as % of merchandise exports) in 1964?
Keep it short and to the point. 13.25. What is the difference between the highest and the second highest Exports(as % of merchandise exports) of 1965?
Give a very brief answer. 15.99. What is the difference between the highest and the lowest Exports(as % of merchandise exports) of 1962?
Your answer should be compact. 17.06. What is the difference between the highest and the lowest Exports(as % of merchandise exports) of 1963?
Provide a succinct answer. 16.8. What is the difference between the highest and the lowest Exports(as % of merchandise exports) of 1964?
Give a very brief answer. 18.12. What is the difference between the highest and the lowest Exports(as % of merchandise exports) of 1965?
Offer a terse response. 19.79. 